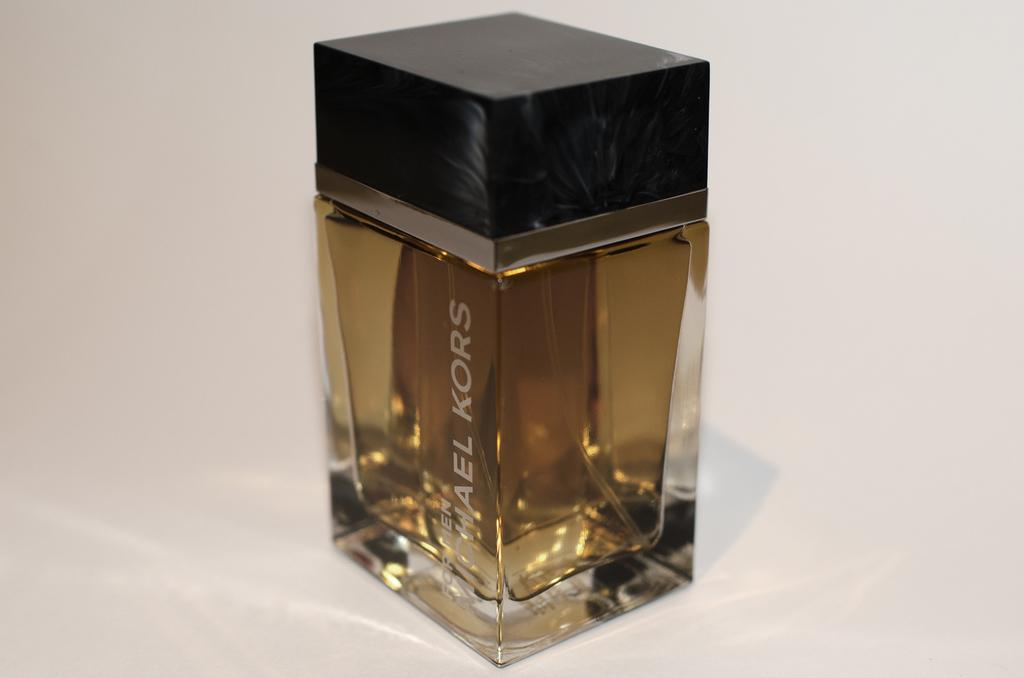Provide a one-sentence caption for the provided image. Bottle of Michael Kors cologne by itself on a table. 